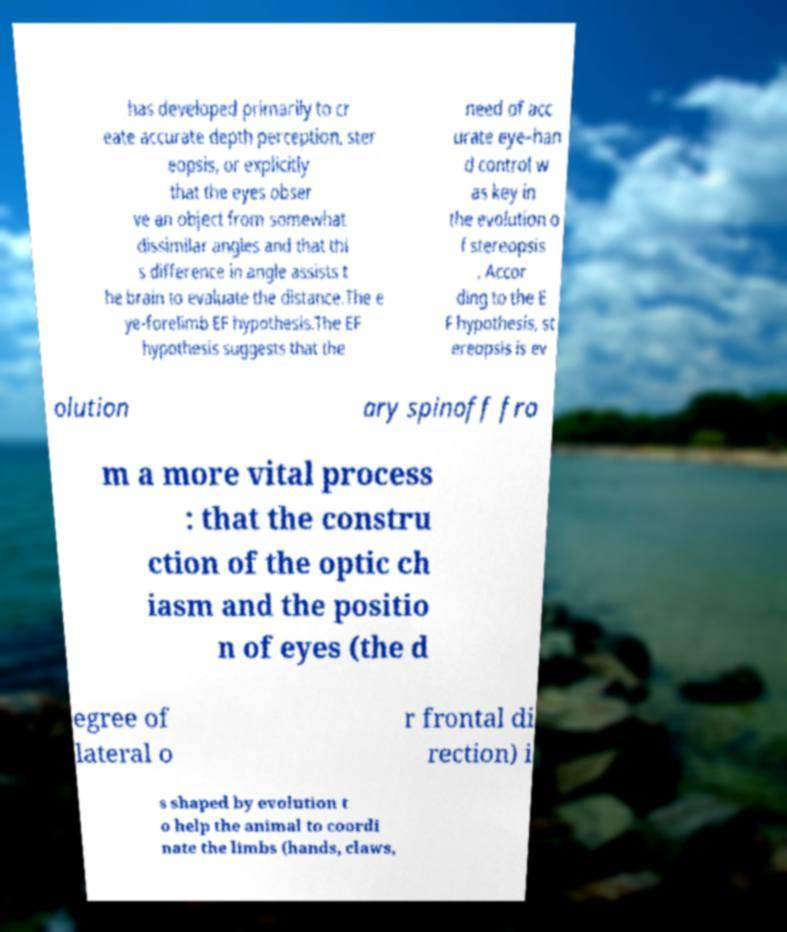Please read and relay the text visible in this image. What does it say? has developed primarily to cr eate accurate depth perception, ster eopsis, or explicitly that the eyes obser ve an object from somewhat dissimilar angles and that thi s difference in angle assists t he brain to evaluate the distance.The e ye-forelimb EF hypothesis.The EF hypothesis suggests that the need of acc urate eye–han d control w as key in the evolution o f stereopsis . Accor ding to the E F hypothesis, st ereopsis is ev olution ary spinoff fro m a more vital process : that the constru ction of the optic ch iasm and the positio n of eyes (the d egree of lateral o r frontal di rection) i s shaped by evolution t o help the animal to coordi nate the limbs (hands, claws, 